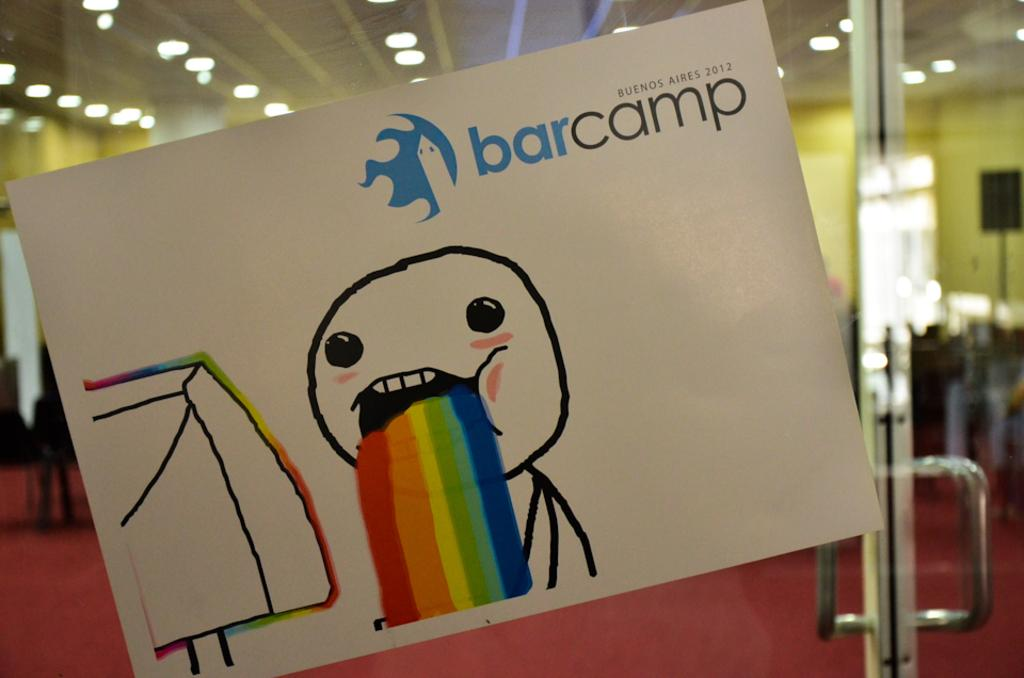<image>
Share a concise interpretation of the image provided. A stick figure looking at a computer monitor and barfing a rainbow with barcamp behind him. 